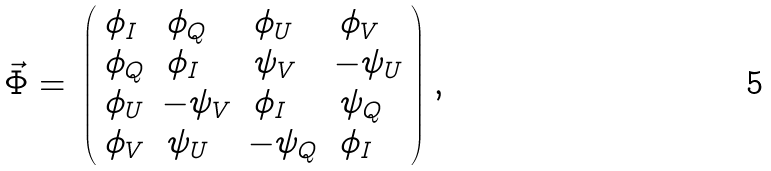<formula> <loc_0><loc_0><loc_500><loc_500>\begin{array} { r c l l } \vec { \Phi } = & \left ( \begin{array} { l l l l } \phi _ { I } & \, \phi _ { Q } & \, \phi _ { U } & \, \phi _ { V } \\ \phi _ { Q } & \, \phi _ { I } & \, \psi _ { V } & - \psi _ { U } \\ \phi _ { U } & - \psi _ { V } & \, \phi _ { I } & \, \psi _ { Q } \\ \phi _ { V } & \, \psi _ { U } & - \psi _ { Q } & \, \phi _ { I } \\ \end{array} \right ) \end{array} ,</formula> 